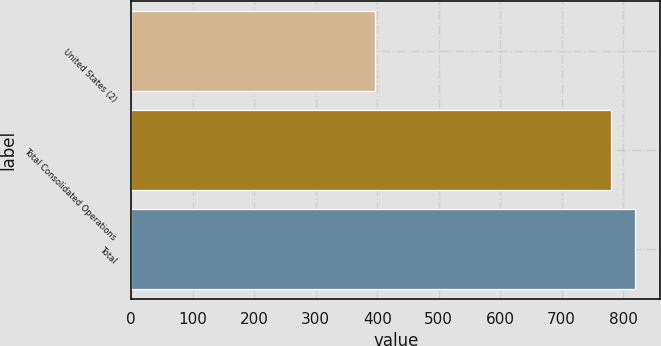<chart> <loc_0><loc_0><loc_500><loc_500><bar_chart><fcel>United States (2)<fcel>Total Consolidated Operations<fcel>Total<nl><fcel>397<fcel>781<fcel>819.4<nl></chart> 